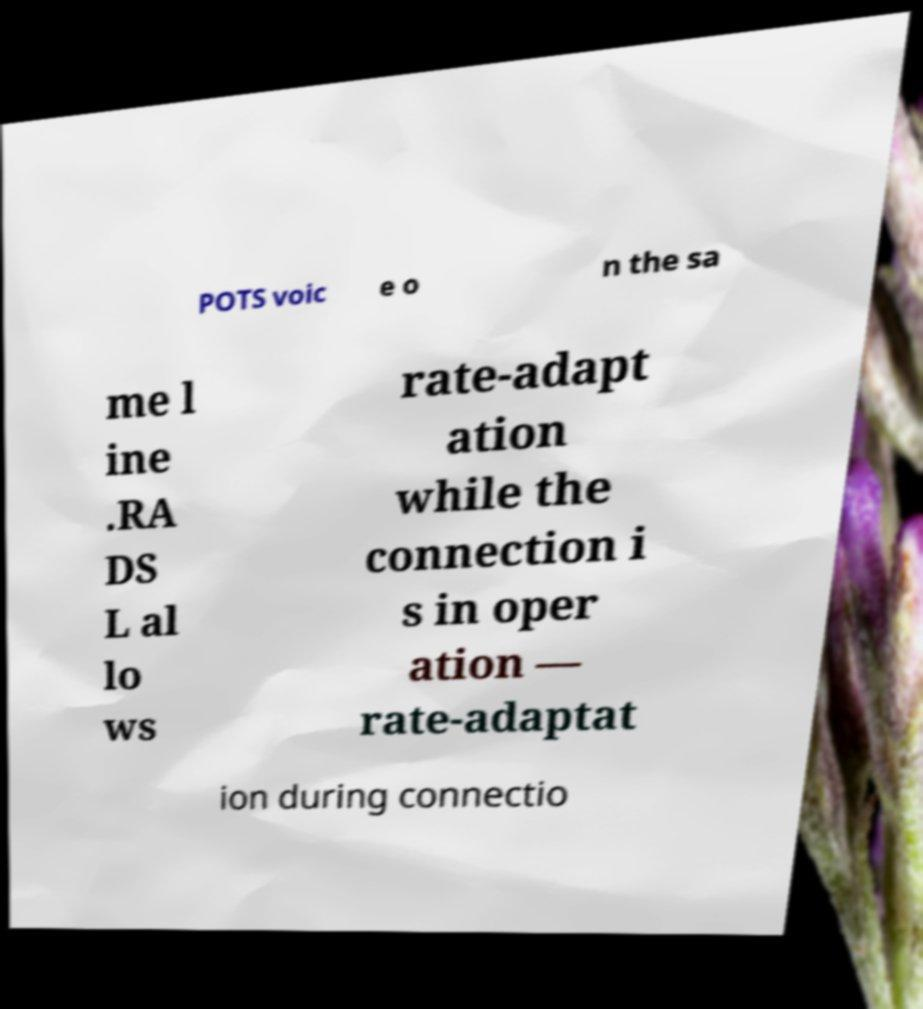I need the written content from this picture converted into text. Can you do that? POTS voic e o n the sa me l ine .RA DS L al lo ws rate-adapt ation while the connection i s in oper ation — rate-adaptat ion during connectio 